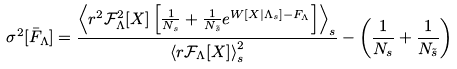<formula> <loc_0><loc_0><loc_500><loc_500>\sigma ^ { 2 } [ \bar { F } _ { \Lambda } ] = \frac { \left < r ^ { 2 } \mathcal { F } ^ { 2 } _ { \Lambda } [ X ] \left [ \frac { 1 } { N _ { s } } + \frac { 1 } { N _ { \tilde { s } } } e ^ { W [ X | \Lambda _ { s } ] - F _ { \Lambda } } \right ] \right > _ { s } } { \left < r \mathcal { F } _ { \Lambda } [ X ] \right > _ { s } ^ { 2 } } - \left ( \frac { 1 } { N _ { s } } + \frac { 1 } { N _ { \tilde { s } } } \right )</formula> 